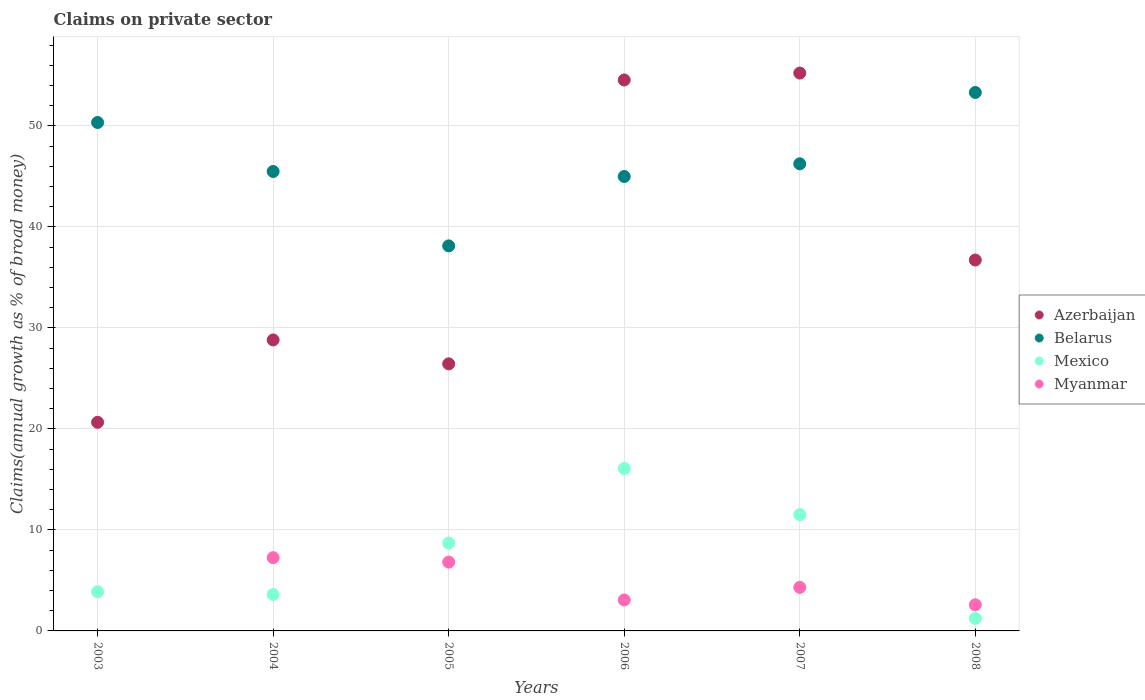How many different coloured dotlines are there?
Your response must be concise. 4. Is the number of dotlines equal to the number of legend labels?
Your answer should be compact. No. What is the percentage of broad money claimed on private sector in Myanmar in 2006?
Ensure brevity in your answer.  3.06. Across all years, what is the maximum percentage of broad money claimed on private sector in Azerbaijan?
Offer a terse response. 55.23. Across all years, what is the minimum percentage of broad money claimed on private sector in Mexico?
Ensure brevity in your answer.  1.24. What is the total percentage of broad money claimed on private sector in Azerbaijan in the graph?
Make the answer very short. 222.39. What is the difference between the percentage of broad money claimed on private sector in Mexico in 2007 and that in 2008?
Your answer should be very brief. 10.27. What is the difference between the percentage of broad money claimed on private sector in Myanmar in 2005 and the percentage of broad money claimed on private sector in Azerbaijan in 2008?
Your answer should be compact. -29.91. What is the average percentage of broad money claimed on private sector in Azerbaijan per year?
Ensure brevity in your answer.  37.07. In the year 2007, what is the difference between the percentage of broad money claimed on private sector in Mexico and percentage of broad money claimed on private sector in Myanmar?
Keep it short and to the point. 7.2. In how many years, is the percentage of broad money claimed on private sector in Myanmar greater than 48 %?
Provide a short and direct response. 0. What is the ratio of the percentage of broad money claimed on private sector in Mexico in 2006 to that in 2008?
Keep it short and to the point. 12.94. Is the percentage of broad money claimed on private sector in Belarus in 2007 less than that in 2008?
Your answer should be very brief. Yes. What is the difference between the highest and the second highest percentage of broad money claimed on private sector in Azerbaijan?
Offer a very short reply. 0.69. What is the difference between the highest and the lowest percentage of broad money claimed on private sector in Mexico?
Your answer should be very brief. 14.83. In how many years, is the percentage of broad money claimed on private sector in Belarus greater than the average percentage of broad money claimed on private sector in Belarus taken over all years?
Make the answer very short. 2. Is it the case that in every year, the sum of the percentage of broad money claimed on private sector in Myanmar and percentage of broad money claimed on private sector in Belarus  is greater than the sum of percentage of broad money claimed on private sector in Azerbaijan and percentage of broad money claimed on private sector in Mexico?
Provide a short and direct response. Yes. Is it the case that in every year, the sum of the percentage of broad money claimed on private sector in Azerbaijan and percentage of broad money claimed on private sector in Belarus  is greater than the percentage of broad money claimed on private sector in Mexico?
Provide a succinct answer. Yes. Is the percentage of broad money claimed on private sector in Azerbaijan strictly less than the percentage of broad money claimed on private sector in Belarus over the years?
Offer a very short reply. No. How many dotlines are there?
Provide a short and direct response. 4. Does the graph contain any zero values?
Offer a terse response. Yes. Where does the legend appear in the graph?
Provide a short and direct response. Center right. How many legend labels are there?
Provide a short and direct response. 4. What is the title of the graph?
Offer a terse response. Claims on private sector. What is the label or title of the X-axis?
Offer a terse response. Years. What is the label or title of the Y-axis?
Ensure brevity in your answer.  Claims(annual growth as % of broad money). What is the Claims(annual growth as % of broad money) in Azerbaijan in 2003?
Give a very brief answer. 20.65. What is the Claims(annual growth as % of broad money) of Belarus in 2003?
Offer a very short reply. 50.33. What is the Claims(annual growth as % of broad money) of Mexico in 2003?
Your answer should be compact. 3.87. What is the Claims(annual growth as % of broad money) in Myanmar in 2003?
Ensure brevity in your answer.  0. What is the Claims(annual growth as % of broad money) of Azerbaijan in 2004?
Your answer should be very brief. 28.81. What is the Claims(annual growth as % of broad money) of Belarus in 2004?
Your response must be concise. 45.48. What is the Claims(annual growth as % of broad money) of Mexico in 2004?
Make the answer very short. 3.61. What is the Claims(annual growth as % of broad money) of Myanmar in 2004?
Offer a terse response. 7.25. What is the Claims(annual growth as % of broad money) in Azerbaijan in 2005?
Offer a terse response. 26.44. What is the Claims(annual growth as % of broad money) in Belarus in 2005?
Offer a terse response. 38.12. What is the Claims(annual growth as % of broad money) in Mexico in 2005?
Provide a short and direct response. 8.7. What is the Claims(annual growth as % of broad money) of Myanmar in 2005?
Keep it short and to the point. 6.81. What is the Claims(annual growth as % of broad money) in Azerbaijan in 2006?
Give a very brief answer. 54.54. What is the Claims(annual growth as % of broad money) of Belarus in 2006?
Offer a terse response. 44.99. What is the Claims(annual growth as % of broad money) of Mexico in 2006?
Provide a short and direct response. 16.08. What is the Claims(annual growth as % of broad money) in Myanmar in 2006?
Your answer should be compact. 3.06. What is the Claims(annual growth as % of broad money) of Azerbaijan in 2007?
Provide a short and direct response. 55.23. What is the Claims(annual growth as % of broad money) of Belarus in 2007?
Make the answer very short. 46.24. What is the Claims(annual growth as % of broad money) of Mexico in 2007?
Keep it short and to the point. 11.51. What is the Claims(annual growth as % of broad money) of Myanmar in 2007?
Make the answer very short. 4.31. What is the Claims(annual growth as % of broad money) of Azerbaijan in 2008?
Your answer should be compact. 36.72. What is the Claims(annual growth as % of broad money) in Belarus in 2008?
Your answer should be compact. 53.31. What is the Claims(annual growth as % of broad money) in Mexico in 2008?
Offer a terse response. 1.24. What is the Claims(annual growth as % of broad money) of Myanmar in 2008?
Provide a short and direct response. 2.59. Across all years, what is the maximum Claims(annual growth as % of broad money) of Azerbaijan?
Provide a short and direct response. 55.23. Across all years, what is the maximum Claims(annual growth as % of broad money) in Belarus?
Your answer should be very brief. 53.31. Across all years, what is the maximum Claims(annual growth as % of broad money) in Mexico?
Provide a short and direct response. 16.08. Across all years, what is the maximum Claims(annual growth as % of broad money) of Myanmar?
Ensure brevity in your answer.  7.25. Across all years, what is the minimum Claims(annual growth as % of broad money) in Azerbaijan?
Your response must be concise. 20.65. Across all years, what is the minimum Claims(annual growth as % of broad money) in Belarus?
Provide a short and direct response. 38.12. Across all years, what is the minimum Claims(annual growth as % of broad money) in Mexico?
Provide a short and direct response. 1.24. What is the total Claims(annual growth as % of broad money) of Azerbaijan in the graph?
Keep it short and to the point. 222.39. What is the total Claims(annual growth as % of broad money) in Belarus in the graph?
Your answer should be compact. 278.48. What is the total Claims(annual growth as % of broad money) in Mexico in the graph?
Your response must be concise. 45.01. What is the total Claims(annual growth as % of broad money) in Myanmar in the graph?
Your response must be concise. 24.03. What is the difference between the Claims(annual growth as % of broad money) of Azerbaijan in 2003 and that in 2004?
Provide a succinct answer. -8.15. What is the difference between the Claims(annual growth as % of broad money) in Belarus in 2003 and that in 2004?
Your answer should be compact. 4.85. What is the difference between the Claims(annual growth as % of broad money) in Mexico in 2003 and that in 2004?
Ensure brevity in your answer.  0.26. What is the difference between the Claims(annual growth as % of broad money) in Azerbaijan in 2003 and that in 2005?
Keep it short and to the point. -5.79. What is the difference between the Claims(annual growth as % of broad money) of Belarus in 2003 and that in 2005?
Offer a terse response. 12.22. What is the difference between the Claims(annual growth as % of broad money) in Mexico in 2003 and that in 2005?
Your response must be concise. -4.83. What is the difference between the Claims(annual growth as % of broad money) of Azerbaijan in 2003 and that in 2006?
Your response must be concise. -33.89. What is the difference between the Claims(annual growth as % of broad money) in Belarus in 2003 and that in 2006?
Give a very brief answer. 5.35. What is the difference between the Claims(annual growth as % of broad money) of Mexico in 2003 and that in 2006?
Your answer should be compact. -12.2. What is the difference between the Claims(annual growth as % of broad money) in Azerbaijan in 2003 and that in 2007?
Your response must be concise. -34.57. What is the difference between the Claims(annual growth as % of broad money) of Belarus in 2003 and that in 2007?
Provide a succinct answer. 4.09. What is the difference between the Claims(annual growth as % of broad money) of Mexico in 2003 and that in 2007?
Make the answer very short. -7.64. What is the difference between the Claims(annual growth as % of broad money) in Azerbaijan in 2003 and that in 2008?
Make the answer very short. -16.06. What is the difference between the Claims(annual growth as % of broad money) in Belarus in 2003 and that in 2008?
Your response must be concise. -2.97. What is the difference between the Claims(annual growth as % of broad money) in Mexico in 2003 and that in 2008?
Provide a short and direct response. 2.63. What is the difference between the Claims(annual growth as % of broad money) of Azerbaijan in 2004 and that in 2005?
Make the answer very short. 2.37. What is the difference between the Claims(annual growth as % of broad money) of Belarus in 2004 and that in 2005?
Your answer should be very brief. 7.37. What is the difference between the Claims(annual growth as % of broad money) of Mexico in 2004 and that in 2005?
Ensure brevity in your answer.  -5.09. What is the difference between the Claims(annual growth as % of broad money) in Myanmar in 2004 and that in 2005?
Ensure brevity in your answer.  0.44. What is the difference between the Claims(annual growth as % of broad money) in Azerbaijan in 2004 and that in 2006?
Provide a short and direct response. -25.74. What is the difference between the Claims(annual growth as % of broad money) in Belarus in 2004 and that in 2006?
Give a very brief answer. 0.5. What is the difference between the Claims(annual growth as % of broad money) in Mexico in 2004 and that in 2006?
Provide a short and direct response. -12.47. What is the difference between the Claims(annual growth as % of broad money) of Myanmar in 2004 and that in 2006?
Give a very brief answer. 4.19. What is the difference between the Claims(annual growth as % of broad money) in Azerbaijan in 2004 and that in 2007?
Your response must be concise. -26.42. What is the difference between the Claims(annual growth as % of broad money) of Belarus in 2004 and that in 2007?
Your response must be concise. -0.76. What is the difference between the Claims(annual growth as % of broad money) in Mexico in 2004 and that in 2007?
Your answer should be very brief. -7.9. What is the difference between the Claims(annual growth as % of broad money) of Myanmar in 2004 and that in 2007?
Make the answer very short. 2.94. What is the difference between the Claims(annual growth as % of broad money) of Azerbaijan in 2004 and that in 2008?
Ensure brevity in your answer.  -7.91. What is the difference between the Claims(annual growth as % of broad money) in Belarus in 2004 and that in 2008?
Your answer should be compact. -7.82. What is the difference between the Claims(annual growth as % of broad money) in Mexico in 2004 and that in 2008?
Your answer should be very brief. 2.37. What is the difference between the Claims(annual growth as % of broad money) of Myanmar in 2004 and that in 2008?
Offer a very short reply. 4.67. What is the difference between the Claims(annual growth as % of broad money) of Azerbaijan in 2005 and that in 2006?
Your response must be concise. -28.1. What is the difference between the Claims(annual growth as % of broad money) of Belarus in 2005 and that in 2006?
Your answer should be very brief. -6.87. What is the difference between the Claims(annual growth as % of broad money) of Mexico in 2005 and that in 2006?
Make the answer very short. -7.37. What is the difference between the Claims(annual growth as % of broad money) in Myanmar in 2005 and that in 2006?
Offer a terse response. 3.75. What is the difference between the Claims(annual growth as % of broad money) of Azerbaijan in 2005 and that in 2007?
Ensure brevity in your answer.  -28.79. What is the difference between the Claims(annual growth as % of broad money) of Belarus in 2005 and that in 2007?
Offer a terse response. -8.13. What is the difference between the Claims(annual growth as % of broad money) of Mexico in 2005 and that in 2007?
Give a very brief answer. -2.81. What is the difference between the Claims(annual growth as % of broad money) in Myanmar in 2005 and that in 2007?
Provide a short and direct response. 2.5. What is the difference between the Claims(annual growth as % of broad money) in Azerbaijan in 2005 and that in 2008?
Offer a terse response. -10.28. What is the difference between the Claims(annual growth as % of broad money) of Belarus in 2005 and that in 2008?
Offer a very short reply. -15.19. What is the difference between the Claims(annual growth as % of broad money) in Mexico in 2005 and that in 2008?
Your response must be concise. 7.46. What is the difference between the Claims(annual growth as % of broad money) in Myanmar in 2005 and that in 2008?
Your response must be concise. 4.23. What is the difference between the Claims(annual growth as % of broad money) of Azerbaijan in 2006 and that in 2007?
Provide a short and direct response. -0.69. What is the difference between the Claims(annual growth as % of broad money) of Belarus in 2006 and that in 2007?
Provide a succinct answer. -1.26. What is the difference between the Claims(annual growth as % of broad money) of Mexico in 2006 and that in 2007?
Offer a very short reply. 4.56. What is the difference between the Claims(annual growth as % of broad money) in Myanmar in 2006 and that in 2007?
Keep it short and to the point. -1.25. What is the difference between the Claims(annual growth as % of broad money) of Azerbaijan in 2006 and that in 2008?
Offer a terse response. 17.82. What is the difference between the Claims(annual growth as % of broad money) in Belarus in 2006 and that in 2008?
Keep it short and to the point. -8.32. What is the difference between the Claims(annual growth as % of broad money) of Mexico in 2006 and that in 2008?
Your answer should be compact. 14.83. What is the difference between the Claims(annual growth as % of broad money) in Myanmar in 2006 and that in 2008?
Your response must be concise. 0.48. What is the difference between the Claims(annual growth as % of broad money) in Azerbaijan in 2007 and that in 2008?
Ensure brevity in your answer.  18.51. What is the difference between the Claims(annual growth as % of broad money) of Belarus in 2007 and that in 2008?
Provide a succinct answer. -7.06. What is the difference between the Claims(annual growth as % of broad money) of Mexico in 2007 and that in 2008?
Your answer should be compact. 10.27. What is the difference between the Claims(annual growth as % of broad money) of Myanmar in 2007 and that in 2008?
Make the answer very short. 1.73. What is the difference between the Claims(annual growth as % of broad money) of Azerbaijan in 2003 and the Claims(annual growth as % of broad money) of Belarus in 2004?
Offer a very short reply. -24.83. What is the difference between the Claims(annual growth as % of broad money) of Azerbaijan in 2003 and the Claims(annual growth as % of broad money) of Mexico in 2004?
Provide a succinct answer. 17.05. What is the difference between the Claims(annual growth as % of broad money) in Azerbaijan in 2003 and the Claims(annual growth as % of broad money) in Myanmar in 2004?
Provide a succinct answer. 13.4. What is the difference between the Claims(annual growth as % of broad money) in Belarus in 2003 and the Claims(annual growth as % of broad money) in Mexico in 2004?
Give a very brief answer. 46.73. What is the difference between the Claims(annual growth as % of broad money) of Belarus in 2003 and the Claims(annual growth as % of broad money) of Myanmar in 2004?
Ensure brevity in your answer.  43.08. What is the difference between the Claims(annual growth as % of broad money) in Mexico in 2003 and the Claims(annual growth as % of broad money) in Myanmar in 2004?
Your answer should be very brief. -3.38. What is the difference between the Claims(annual growth as % of broad money) of Azerbaijan in 2003 and the Claims(annual growth as % of broad money) of Belarus in 2005?
Ensure brevity in your answer.  -17.46. What is the difference between the Claims(annual growth as % of broad money) in Azerbaijan in 2003 and the Claims(annual growth as % of broad money) in Mexico in 2005?
Offer a terse response. 11.95. What is the difference between the Claims(annual growth as % of broad money) of Azerbaijan in 2003 and the Claims(annual growth as % of broad money) of Myanmar in 2005?
Offer a terse response. 13.84. What is the difference between the Claims(annual growth as % of broad money) of Belarus in 2003 and the Claims(annual growth as % of broad money) of Mexico in 2005?
Your answer should be compact. 41.63. What is the difference between the Claims(annual growth as % of broad money) in Belarus in 2003 and the Claims(annual growth as % of broad money) in Myanmar in 2005?
Your answer should be very brief. 43.52. What is the difference between the Claims(annual growth as % of broad money) in Mexico in 2003 and the Claims(annual growth as % of broad money) in Myanmar in 2005?
Provide a short and direct response. -2.94. What is the difference between the Claims(annual growth as % of broad money) in Azerbaijan in 2003 and the Claims(annual growth as % of broad money) in Belarus in 2006?
Provide a succinct answer. -24.33. What is the difference between the Claims(annual growth as % of broad money) of Azerbaijan in 2003 and the Claims(annual growth as % of broad money) of Mexico in 2006?
Make the answer very short. 4.58. What is the difference between the Claims(annual growth as % of broad money) in Azerbaijan in 2003 and the Claims(annual growth as % of broad money) in Myanmar in 2006?
Your answer should be very brief. 17.59. What is the difference between the Claims(annual growth as % of broad money) of Belarus in 2003 and the Claims(annual growth as % of broad money) of Mexico in 2006?
Your response must be concise. 34.26. What is the difference between the Claims(annual growth as % of broad money) of Belarus in 2003 and the Claims(annual growth as % of broad money) of Myanmar in 2006?
Your response must be concise. 47.27. What is the difference between the Claims(annual growth as % of broad money) in Mexico in 2003 and the Claims(annual growth as % of broad money) in Myanmar in 2006?
Give a very brief answer. 0.81. What is the difference between the Claims(annual growth as % of broad money) of Azerbaijan in 2003 and the Claims(annual growth as % of broad money) of Belarus in 2007?
Offer a very short reply. -25.59. What is the difference between the Claims(annual growth as % of broad money) of Azerbaijan in 2003 and the Claims(annual growth as % of broad money) of Mexico in 2007?
Your answer should be compact. 9.14. What is the difference between the Claims(annual growth as % of broad money) in Azerbaijan in 2003 and the Claims(annual growth as % of broad money) in Myanmar in 2007?
Your answer should be very brief. 16.34. What is the difference between the Claims(annual growth as % of broad money) in Belarus in 2003 and the Claims(annual growth as % of broad money) in Mexico in 2007?
Offer a terse response. 38.82. What is the difference between the Claims(annual growth as % of broad money) in Belarus in 2003 and the Claims(annual growth as % of broad money) in Myanmar in 2007?
Your answer should be compact. 46.02. What is the difference between the Claims(annual growth as % of broad money) of Mexico in 2003 and the Claims(annual growth as % of broad money) of Myanmar in 2007?
Provide a succinct answer. -0.44. What is the difference between the Claims(annual growth as % of broad money) in Azerbaijan in 2003 and the Claims(annual growth as % of broad money) in Belarus in 2008?
Your answer should be compact. -32.65. What is the difference between the Claims(annual growth as % of broad money) of Azerbaijan in 2003 and the Claims(annual growth as % of broad money) of Mexico in 2008?
Your answer should be very brief. 19.41. What is the difference between the Claims(annual growth as % of broad money) of Azerbaijan in 2003 and the Claims(annual growth as % of broad money) of Myanmar in 2008?
Keep it short and to the point. 18.07. What is the difference between the Claims(annual growth as % of broad money) in Belarus in 2003 and the Claims(annual growth as % of broad money) in Mexico in 2008?
Offer a very short reply. 49.09. What is the difference between the Claims(annual growth as % of broad money) in Belarus in 2003 and the Claims(annual growth as % of broad money) in Myanmar in 2008?
Offer a terse response. 47.75. What is the difference between the Claims(annual growth as % of broad money) in Mexico in 2003 and the Claims(annual growth as % of broad money) in Myanmar in 2008?
Provide a succinct answer. 1.29. What is the difference between the Claims(annual growth as % of broad money) of Azerbaijan in 2004 and the Claims(annual growth as % of broad money) of Belarus in 2005?
Make the answer very short. -9.31. What is the difference between the Claims(annual growth as % of broad money) of Azerbaijan in 2004 and the Claims(annual growth as % of broad money) of Mexico in 2005?
Give a very brief answer. 20.11. What is the difference between the Claims(annual growth as % of broad money) of Azerbaijan in 2004 and the Claims(annual growth as % of broad money) of Myanmar in 2005?
Your response must be concise. 21.99. What is the difference between the Claims(annual growth as % of broad money) in Belarus in 2004 and the Claims(annual growth as % of broad money) in Mexico in 2005?
Give a very brief answer. 36.78. What is the difference between the Claims(annual growth as % of broad money) of Belarus in 2004 and the Claims(annual growth as % of broad money) of Myanmar in 2005?
Your answer should be very brief. 38.67. What is the difference between the Claims(annual growth as % of broad money) of Mexico in 2004 and the Claims(annual growth as % of broad money) of Myanmar in 2005?
Make the answer very short. -3.2. What is the difference between the Claims(annual growth as % of broad money) in Azerbaijan in 2004 and the Claims(annual growth as % of broad money) in Belarus in 2006?
Give a very brief answer. -16.18. What is the difference between the Claims(annual growth as % of broad money) of Azerbaijan in 2004 and the Claims(annual growth as % of broad money) of Mexico in 2006?
Provide a succinct answer. 12.73. What is the difference between the Claims(annual growth as % of broad money) in Azerbaijan in 2004 and the Claims(annual growth as % of broad money) in Myanmar in 2006?
Your response must be concise. 25.74. What is the difference between the Claims(annual growth as % of broad money) in Belarus in 2004 and the Claims(annual growth as % of broad money) in Mexico in 2006?
Your answer should be compact. 29.41. What is the difference between the Claims(annual growth as % of broad money) in Belarus in 2004 and the Claims(annual growth as % of broad money) in Myanmar in 2006?
Provide a short and direct response. 42.42. What is the difference between the Claims(annual growth as % of broad money) of Mexico in 2004 and the Claims(annual growth as % of broad money) of Myanmar in 2006?
Keep it short and to the point. 0.55. What is the difference between the Claims(annual growth as % of broad money) in Azerbaijan in 2004 and the Claims(annual growth as % of broad money) in Belarus in 2007?
Give a very brief answer. -17.44. What is the difference between the Claims(annual growth as % of broad money) in Azerbaijan in 2004 and the Claims(annual growth as % of broad money) in Mexico in 2007?
Your response must be concise. 17.29. What is the difference between the Claims(annual growth as % of broad money) of Azerbaijan in 2004 and the Claims(annual growth as % of broad money) of Myanmar in 2007?
Your answer should be compact. 24.49. What is the difference between the Claims(annual growth as % of broad money) of Belarus in 2004 and the Claims(annual growth as % of broad money) of Mexico in 2007?
Your response must be concise. 33.97. What is the difference between the Claims(annual growth as % of broad money) of Belarus in 2004 and the Claims(annual growth as % of broad money) of Myanmar in 2007?
Keep it short and to the point. 41.17. What is the difference between the Claims(annual growth as % of broad money) of Mexico in 2004 and the Claims(annual growth as % of broad money) of Myanmar in 2007?
Make the answer very short. -0.7. What is the difference between the Claims(annual growth as % of broad money) in Azerbaijan in 2004 and the Claims(annual growth as % of broad money) in Belarus in 2008?
Give a very brief answer. -24.5. What is the difference between the Claims(annual growth as % of broad money) in Azerbaijan in 2004 and the Claims(annual growth as % of broad money) in Mexico in 2008?
Keep it short and to the point. 27.56. What is the difference between the Claims(annual growth as % of broad money) in Azerbaijan in 2004 and the Claims(annual growth as % of broad money) in Myanmar in 2008?
Offer a very short reply. 26.22. What is the difference between the Claims(annual growth as % of broad money) of Belarus in 2004 and the Claims(annual growth as % of broad money) of Mexico in 2008?
Your answer should be compact. 44.24. What is the difference between the Claims(annual growth as % of broad money) in Belarus in 2004 and the Claims(annual growth as % of broad money) in Myanmar in 2008?
Make the answer very short. 42.9. What is the difference between the Claims(annual growth as % of broad money) in Mexico in 2004 and the Claims(annual growth as % of broad money) in Myanmar in 2008?
Give a very brief answer. 1.02. What is the difference between the Claims(annual growth as % of broad money) of Azerbaijan in 2005 and the Claims(annual growth as % of broad money) of Belarus in 2006?
Offer a very short reply. -18.55. What is the difference between the Claims(annual growth as % of broad money) of Azerbaijan in 2005 and the Claims(annual growth as % of broad money) of Mexico in 2006?
Provide a succinct answer. 10.36. What is the difference between the Claims(annual growth as % of broad money) in Azerbaijan in 2005 and the Claims(annual growth as % of broad money) in Myanmar in 2006?
Ensure brevity in your answer.  23.38. What is the difference between the Claims(annual growth as % of broad money) in Belarus in 2005 and the Claims(annual growth as % of broad money) in Mexico in 2006?
Ensure brevity in your answer.  22.04. What is the difference between the Claims(annual growth as % of broad money) of Belarus in 2005 and the Claims(annual growth as % of broad money) of Myanmar in 2006?
Provide a succinct answer. 35.05. What is the difference between the Claims(annual growth as % of broad money) in Mexico in 2005 and the Claims(annual growth as % of broad money) in Myanmar in 2006?
Provide a succinct answer. 5.64. What is the difference between the Claims(annual growth as % of broad money) of Azerbaijan in 2005 and the Claims(annual growth as % of broad money) of Belarus in 2007?
Give a very brief answer. -19.8. What is the difference between the Claims(annual growth as % of broad money) in Azerbaijan in 2005 and the Claims(annual growth as % of broad money) in Mexico in 2007?
Offer a terse response. 14.93. What is the difference between the Claims(annual growth as % of broad money) in Azerbaijan in 2005 and the Claims(annual growth as % of broad money) in Myanmar in 2007?
Ensure brevity in your answer.  22.13. What is the difference between the Claims(annual growth as % of broad money) in Belarus in 2005 and the Claims(annual growth as % of broad money) in Mexico in 2007?
Give a very brief answer. 26.61. What is the difference between the Claims(annual growth as % of broad money) of Belarus in 2005 and the Claims(annual growth as % of broad money) of Myanmar in 2007?
Give a very brief answer. 33.8. What is the difference between the Claims(annual growth as % of broad money) in Mexico in 2005 and the Claims(annual growth as % of broad money) in Myanmar in 2007?
Make the answer very short. 4.39. What is the difference between the Claims(annual growth as % of broad money) in Azerbaijan in 2005 and the Claims(annual growth as % of broad money) in Belarus in 2008?
Your response must be concise. -26.87. What is the difference between the Claims(annual growth as % of broad money) of Azerbaijan in 2005 and the Claims(annual growth as % of broad money) of Mexico in 2008?
Offer a terse response. 25.2. What is the difference between the Claims(annual growth as % of broad money) in Azerbaijan in 2005 and the Claims(annual growth as % of broad money) in Myanmar in 2008?
Ensure brevity in your answer.  23.85. What is the difference between the Claims(annual growth as % of broad money) of Belarus in 2005 and the Claims(annual growth as % of broad money) of Mexico in 2008?
Offer a very short reply. 36.88. What is the difference between the Claims(annual growth as % of broad money) of Belarus in 2005 and the Claims(annual growth as % of broad money) of Myanmar in 2008?
Make the answer very short. 35.53. What is the difference between the Claims(annual growth as % of broad money) of Mexico in 2005 and the Claims(annual growth as % of broad money) of Myanmar in 2008?
Ensure brevity in your answer.  6.11. What is the difference between the Claims(annual growth as % of broad money) in Azerbaijan in 2006 and the Claims(annual growth as % of broad money) in Belarus in 2007?
Give a very brief answer. 8.3. What is the difference between the Claims(annual growth as % of broad money) of Azerbaijan in 2006 and the Claims(annual growth as % of broad money) of Mexico in 2007?
Make the answer very short. 43.03. What is the difference between the Claims(annual growth as % of broad money) in Azerbaijan in 2006 and the Claims(annual growth as % of broad money) in Myanmar in 2007?
Your answer should be very brief. 50.23. What is the difference between the Claims(annual growth as % of broad money) in Belarus in 2006 and the Claims(annual growth as % of broad money) in Mexico in 2007?
Your answer should be compact. 33.48. What is the difference between the Claims(annual growth as % of broad money) in Belarus in 2006 and the Claims(annual growth as % of broad money) in Myanmar in 2007?
Offer a terse response. 40.67. What is the difference between the Claims(annual growth as % of broad money) in Mexico in 2006 and the Claims(annual growth as % of broad money) in Myanmar in 2007?
Offer a terse response. 11.76. What is the difference between the Claims(annual growth as % of broad money) in Azerbaijan in 2006 and the Claims(annual growth as % of broad money) in Belarus in 2008?
Provide a short and direct response. 1.24. What is the difference between the Claims(annual growth as % of broad money) of Azerbaijan in 2006 and the Claims(annual growth as % of broad money) of Mexico in 2008?
Offer a terse response. 53.3. What is the difference between the Claims(annual growth as % of broad money) in Azerbaijan in 2006 and the Claims(annual growth as % of broad money) in Myanmar in 2008?
Provide a succinct answer. 51.96. What is the difference between the Claims(annual growth as % of broad money) of Belarus in 2006 and the Claims(annual growth as % of broad money) of Mexico in 2008?
Your answer should be compact. 43.75. What is the difference between the Claims(annual growth as % of broad money) in Belarus in 2006 and the Claims(annual growth as % of broad money) in Myanmar in 2008?
Your answer should be very brief. 42.4. What is the difference between the Claims(annual growth as % of broad money) in Mexico in 2006 and the Claims(annual growth as % of broad money) in Myanmar in 2008?
Your answer should be compact. 13.49. What is the difference between the Claims(annual growth as % of broad money) of Azerbaijan in 2007 and the Claims(annual growth as % of broad money) of Belarus in 2008?
Offer a terse response. 1.92. What is the difference between the Claims(annual growth as % of broad money) of Azerbaijan in 2007 and the Claims(annual growth as % of broad money) of Mexico in 2008?
Give a very brief answer. 53.99. What is the difference between the Claims(annual growth as % of broad money) of Azerbaijan in 2007 and the Claims(annual growth as % of broad money) of Myanmar in 2008?
Offer a very short reply. 52.64. What is the difference between the Claims(annual growth as % of broad money) in Belarus in 2007 and the Claims(annual growth as % of broad money) in Mexico in 2008?
Provide a short and direct response. 45. What is the difference between the Claims(annual growth as % of broad money) in Belarus in 2007 and the Claims(annual growth as % of broad money) in Myanmar in 2008?
Your answer should be compact. 43.66. What is the difference between the Claims(annual growth as % of broad money) of Mexico in 2007 and the Claims(annual growth as % of broad money) of Myanmar in 2008?
Your answer should be compact. 8.92. What is the average Claims(annual growth as % of broad money) of Azerbaijan per year?
Give a very brief answer. 37.07. What is the average Claims(annual growth as % of broad money) in Belarus per year?
Your answer should be compact. 46.41. What is the average Claims(annual growth as % of broad money) of Mexico per year?
Provide a succinct answer. 7.5. What is the average Claims(annual growth as % of broad money) in Myanmar per year?
Your answer should be very brief. 4.01. In the year 2003, what is the difference between the Claims(annual growth as % of broad money) in Azerbaijan and Claims(annual growth as % of broad money) in Belarus?
Your answer should be compact. -29.68. In the year 2003, what is the difference between the Claims(annual growth as % of broad money) in Azerbaijan and Claims(annual growth as % of broad money) in Mexico?
Your answer should be very brief. 16.78. In the year 2003, what is the difference between the Claims(annual growth as % of broad money) of Belarus and Claims(annual growth as % of broad money) of Mexico?
Provide a succinct answer. 46.46. In the year 2004, what is the difference between the Claims(annual growth as % of broad money) in Azerbaijan and Claims(annual growth as % of broad money) in Belarus?
Your answer should be very brief. -16.68. In the year 2004, what is the difference between the Claims(annual growth as % of broad money) in Azerbaijan and Claims(annual growth as % of broad money) in Mexico?
Ensure brevity in your answer.  25.2. In the year 2004, what is the difference between the Claims(annual growth as % of broad money) in Azerbaijan and Claims(annual growth as % of broad money) in Myanmar?
Offer a terse response. 21.55. In the year 2004, what is the difference between the Claims(annual growth as % of broad money) in Belarus and Claims(annual growth as % of broad money) in Mexico?
Ensure brevity in your answer.  41.88. In the year 2004, what is the difference between the Claims(annual growth as % of broad money) in Belarus and Claims(annual growth as % of broad money) in Myanmar?
Provide a short and direct response. 38.23. In the year 2004, what is the difference between the Claims(annual growth as % of broad money) of Mexico and Claims(annual growth as % of broad money) of Myanmar?
Make the answer very short. -3.64. In the year 2005, what is the difference between the Claims(annual growth as % of broad money) in Azerbaijan and Claims(annual growth as % of broad money) in Belarus?
Offer a very short reply. -11.68. In the year 2005, what is the difference between the Claims(annual growth as % of broad money) of Azerbaijan and Claims(annual growth as % of broad money) of Mexico?
Provide a short and direct response. 17.74. In the year 2005, what is the difference between the Claims(annual growth as % of broad money) in Azerbaijan and Claims(annual growth as % of broad money) in Myanmar?
Ensure brevity in your answer.  19.63. In the year 2005, what is the difference between the Claims(annual growth as % of broad money) of Belarus and Claims(annual growth as % of broad money) of Mexico?
Provide a succinct answer. 29.42. In the year 2005, what is the difference between the Claims(annual growth as % of broad money) in Belarus and Claims(annual growth as % of broad money) in Myanmar?
Make the answer very short. 31.3. In the year 2005, what is the difference between the Claims(annual growth as % of broad money) in Mexico and Claims(annual growth as % of broad money) in Myanmar?
Your answer should be very brief. 1.89. In the year 2006, what is the difference between the Claims(annual growth as % of broad money) of Azerbaijan and Claims(annual growth as % of broad money) of Belarus?
Provide a succinct answer. 9.56. In the year 2006, what is the difference between the Claims(annual growth as % of broad money) of Azerbaijan and Claims(annual growth as % of broad money) of Mexico?
Make the answer very short. 38.47. In the year 2006, what is the difference between the Claims(annual growth as % of broad money) in Azerbaijan and Claims(annual growth as % of broad money) in Myanmar?
Ensure brevity in your answer.  51.48. In the year 2006, what is the difference between the Claims(annual growth as % of broad money) of Belarus and Claims(annual growth as % of broad money) of Mexico?
Your answer should be very brief. 28.91. In the year 2006, what is the difference between the Claims(annual growth as % of broad money) in Belarus and Claims(annual growth as % of broad money) in Myanmar?
Offer a terse response. 41.92. In the year 2006, what is the difference between the Claims(annual growth as % of broad money) of Mexico and Claims(annual growth as % of broad money) of Myanmar?
Provide a succinct answer. 13.01. In the year 2007, what is the difference between the Claims(annual growth as % of broad money) of Azerbaijan and Claims(annual growth as % of broad money) of Belarus?
Make the answer very short. 8.98. In the year 2007, what is the difference between the Claims(annual growth as % of broad money) in Azerbaijan and Claims(annual growth as % of broad money) in Mexico?
Keep it short and to the point. 43.72. In the year 2007, what is the difference between the Claims(annual growth as % of broad money) of Azerbaijan and Claims(annual growth as % of broad money) of Myanmar?
Offer a very short reply. 50.91. In the year 2007, what is the difference between the Claims(annual growth as % of broad money) of Belarus and Claims(annual growth as % of broad money) of Mexico?
Keep it short and to the point. 34.73. In the year 2007, what is the difference between the Claims(annual growth as % of broad money) of Belarus and Claims(annual growth as % of broad money) of Myanmar?
Provide a short and direct response. 41.93. In the year 2007, what is the difference between the Claims(annual growth as % of broad money) in Mexico and Claims(annual growth as % of broad money) in Myanmar?
Give a very brief answer. 7.2. In the year 2008, what is the difference between the Claims(annual growth as % of broad money) of Azerbaijan and Claims(annual growth as % of broad money) of Belarus?
Your response must be concise. -16.59. In the year 2008, what is the difference between the Claims(annual growth as % of broad money) of Azerbaijan and Claims(annual growth as % of broad money) of Mexico?
Ensure brevity in your answer.  35.48. In the year 2008, what is the difference between the Claims(annual growth as % of broad money) in Azerbaijan and Claims(annual growth as % of broad money) in Myanmar?
Provide a short and direct response. 34.13. In the year 2008, what is the difference between the Claims(annual growth as % of broad money) in Belarus and Claims(annual growth as % of broad money) in Mexico?
Offer a terse response. 52.06. In the year 2008, what is the difference between the Claims(annual growth as % of broad money) of Belarus and Claims(annual growth as % of broad money) of Myanmar?
Ensure brevity in your answer.  50.72. In the year 2008, what is the difference between the Claims(annual growth as % of broad money) of Mexico and Claims(annual growth as % of broad money) of Myanmar?
Provide a succinct answer. -1.35. What is the ratio of the Claims(annual growth as % of broad money) in Azerbaijan in 2003 to that in 2004?
Offer a terse response. 0.72. What is the ratio of the Claims(annual growth as % of broad money) in Belarus in 2003 to that in 2004?
Ensure brevity in your answer.  1.11. What is the ratio of the Claims(annual growth as % of broad money) of Mexico in 2003 to that in 2004?
Make the answer very short. 1.07. What is the ratio of the Claims(annual growth as % of broad money) of Azerbaijan in 2003 to that in 2005?
Ensure brevity in your answer.  0.78. What is the ratio of the Claims(annual growth as % of broad money) in Belarus in 2003 to that in 2005?
Provide a succinct answer. 1.32. What is the ratio of the Claims(annual growth as % of broad money) of Mexico in 2003 to that in 2005?
Provide a succinct answer. 0.45. What is the ratio of the Claims(annual growth as % of broad money) of Azerbaijan in 2003 to that in 2006?
Make the answer very short. 0.38. What is the ratio of the Claims(annual growth as % of broad money) of Belarus in 2003 to that in 2006?
Your response must be concise. 1.12. What is the ratio of the Claims(annual growth as % of broad money) in Mexico in 2003 to that in 2006?
Provide a short and direct response. 0.24. What is the ratio of the Claims(annual growth as % of broad money) of Azerbaijan in 2003 to that in 2007?
Provide a succinct answer. 0.37. What is the ratio of the Claims(annual growth as % of broad money) of Belarus in 2003 to that in 2007?
Ensure brevity in your answer.  1.09. What is the ratio of the Claims(annual growth as % of broad money) of Mexico in 2003 to that in 2007?
Ensure brevity in your answer.  0.34. What is the ratio of the Claims(annual growth as % of broad money) of Azerbaijan in 2003 to that in 2008?
Your answer should be very brief. 0.56. What is the ratio of the Claims(annual growth as % of broad money) of Belarus in 2003 to that in 2008?
Provide a succinct answer. 0.94. What is the ratio of the Claims(annual growth as % of broad money) in Mexico in 2003 to that in 2008?
Keep it short and to the point. 3.12. What is the ratio of the Claims(annual growth as % of broad money) of Azerbaijan in 2004 to that in 2005?
Provide a succinct answer. 1.09. What is the ratio of the Claims(annual growth as % of broad money) of Belarus in 2004 to that in 2005?
Ensure brevity in your answer.  1.19. What is the ratio of the Claims(annual growth as % of broad money) in Mexico in 2004 to that in 2005?
Your answer should be very brief. 0.41. What is the ratio of the Claims(annual growth as % of broad money) in Myanmar in 2004 to that in 2005?
Your response must be concise. 1.06. What is the ratio of the Claims(annual growth as % of broad money) in Azerbaijan in 2004 to that in 2006?
Give a very brief answer. 0.53. What is the ratio of the Claims(annual growth as % of broad money) in Mexico in 2004 to that in 2006?
Your answer should be compact. 0.22. What is the ratio of the Claims(annual growth as % of broad money) of Myanmar in 2004 to that in 2006?
Make the answer very short. 2.37. What is the ratio of the Claims(annual growth as % of broad money) of Azerbaijan in 2004 to that in 2007?
Your response must be concise. 0.52. What is the ratio of the Claims(annual growth as % of broad money) of Belarus in 2004 to that in 2007?
Keep it short and to the point. 0.98. What is the ratio of the Claims(annual growth as % of broad money) of Mexico in 2004 to that in 2007?
Ensure brevity in your answer.  0.31. What is the ratio of the Claims(annual growth as % of broad money) in Myanmar in 2004 to that in 2007?
Offer a terse response. 1.68. What is the ratio of the Claims(annual growth as % of broad money) of Azerbaijan in 2004 to that in 2008?
Give a very brief answer. 0.78. What is the ratio of the Claims(annual growth as % of broad money) in Belarus in 2004 to that in 2008?
Keep it short and to the point. 0.85. What is the ratio of the Claims(annual growth as % of broad money) in Mexico in 2004 to that in 2008?
Give a very brief answer. 2.9. What is the ratio of the Claims(annual growth as % of broad money) of Myanmar in 2004 to that in 2008?
Offer a terse response. 2.8. What is the ratio of the Claims(annual growth as % of broad money) of Azerbaijan in 2005 to that in 2006?
Your answer should be compact. 0.48. What is the ratio of the Claims(annual growth as % of broad money) of Belarus in 2005 to that in 2006?
Your answer should be very brief. 0.85. What is the ratio of the Claims(annual growth as % of broad money) of Mexico in 2005 to that in 2006?
Make the answer very short. 0.54. What is the ratio of the Claims(annual growth as % of broad money) of Myanmar in 2005 to that in 2006?
Provide a short and direct response. 2.22. What is the ratio of the Claims(annual growth as % of broad money) in Azerbaijan in 2005 to that in 2007?
Provide a short and direct response. 0.48. What is the ratio of the Claims(annual growth as % of broad money) in Belarus in 2005 to that in 2007?
Provide a succinct answer. 0.82. What is the ratio of the Claims(annual growth as % of broad money) of Mexico in 2005 to that in 2007?
Offer a very short reply. 0.76. What is the ratio of the Claims(annual growth as % of broad money) in Myanmar in 2005 to that in 2007?
Offer a very short reply. 1.58. What is the ratio of the Claims(annual growth as % of broad money) in Azerbaijan in 2005 to that in 2008?
Provide a succinct answer. 0.72. What is the ratio of the Claims(annual growth as % of broad money) in Belarus in 2005 to that in 2008?
Provide a short and direct response. 0.72. What is the ratio of the Claims(annual growth as % of broad money) in Mexico in 2005 to that in 2008?
Ensure brevity in your answer.  7. What is the ratio of the Claims(annual growth as % of broad money) of Myanmar in 2005 to that in 2008?
Your answer should be compact. 2.63. What is the ratio of the Claims(annual growth as % of broad money) of Azerbaijan in 2006 to that in 2007?
Give a very brief answer. 0.99. What is the ratio of the Claims(annual growth as % of broad money) of Belarus in 2006 to that in 2007?
Your response must be concise. 0.97. What is the ratio of the Claims(annual growth as % of broad money) in Mexico in 2006 to that in 2007?
Give a very brief answer. 1.4. What is the ratio of the Claims(annual growth as % of broad money) of Myanmar in 2006 to that in 2007?
Your answer should be compact. 0.71. What is the ratio of the Claims(annual growth as % of broad money) in Azerbaijan in 2006 to that in 2008?
Make the answer very short. 1.49. What is the ratio of the Claims(annual growth as % of broad money) of Belarus in 2006 to that in 2008?
Offer a very short reply. 0.84. What is the ratio of the Claims(annual growth as % of broad money) of Mexico in 2006 to that in 2008?
Keep it short and to the point. 12.94. What is the ratio of the Claims(annual growth as % of broad money) in Myanmar in 2006 to that in 2008?
Your response must be concise. 1.18. What is the ratio of the Claims(annual growth as % of broad money) of Azerbaijan in 2007 to that in 2008?
Offer a very short reply. 1.5. What is the ratio of the Claims(annual growth as % of broad money) in Belarus in 2007 to that in 2008?
Keep it short and to the point. 0.87. What is the ratio of the Claims(annual growth as % of broad money) of Mexico in 2007 to that in 2008?
Offer a very short reply. 9.27. What is the ratio of the Claims(annual growth as % of broad money) in Myanmar in 2007 to that in 2008?
Your answer should be compact. 1.67. What is the difference between the highest and the second highest Claims(annual growth as % of broad money) in Azerbaijan?
Give a very brief answer. 0.69. What is the difference between the highest and the second highest Claims(annual growth as % of broad money) of Belarus?
Give a very brief answer. 2.97. What is the difference between the highest and the second highest Claims(annual growth as % of broad money) of Mexico?
Your response must be concise. 4.56. What is the difference between the highest and the second highest Claims(annual growth as % of broad money) of Myanmar?
Provide a succinct answer. 0.44. What is the difference between the highest and the lowest Claims(annual growth as % of broad money) of Azerbaijan?
Provide a short and direct response. 34.57. What is the difference between the highest and the lowest Claims(annual growth as % of broad money) in Belarus?
Your answer should be very brief. 15.19. What is the difference between the highest and the lowest Claims(annual growth as % of broad money) in Mexico?
Provide a short and direct response. 14.83. What is the difference between the highest and the lowest Claims(annual growth as % of broad money) of Myanmar?
Offer a very short reply. 7.25. 